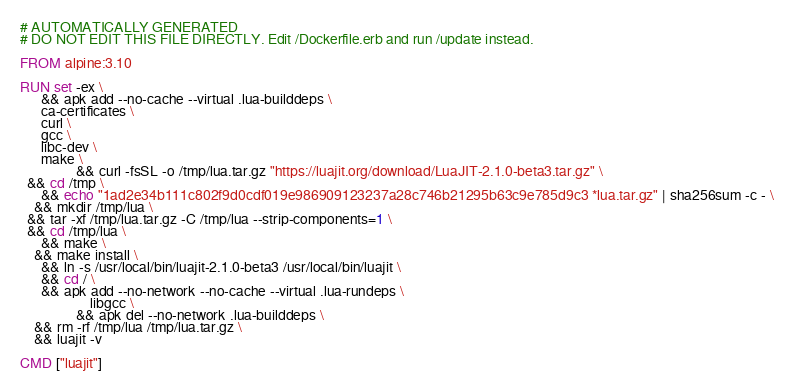Convert code to text. <code><loc_0><loc_0><loc_500><loc_500><_Dockerfile_># AUTOMATICALLY GENERATED
# DO NOT EDIT THIS FILE DIRECTLY. Edit /Dockerfile.erb and run /update instead.

FROM alpine:3.10

RUN set -ex \
      && apk add --no-cache --virtual .lua-builddeps \
      ca-certificates \
      curl \
      gcc \
      libc-dev \
      make \
                && curl -fsSL -o /tmp/lua.tar.gz "https://luajit.org/download/LuaJIT-2.1.0-beta3.tar.gz" \
  && cd /tmp \
      && echo "1ad2e34b111c802f9d0cdf019e986909123237a28c746b21295b63c9e785d9c3 *lua.tar.gz" | sha256sum -c - \
    && mkdir /tmp/lua \
  && tar -xf /tmp/lua.tar.gz -C /tmp/lua --strip-components=1 \
  && cd /tmp/lua \
      && make \
    && make install \
      && ln -s /usr/local/bin/luajit-2.1.0-beta3 /usr/local/bin/luajit \
      && cd / \
      && apk add --no-network --no-cache --virtual .lua-rundeps \
                    libgcc \
                && apk del --no-network .lua-builddeps \
    && rm -rf /tmp/lua /tmp/lua.tar.gz \
    && luajit -v

CMD ["luajit"]
</code> 